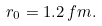<formula> <loc_0><loc_0><loc_500><loc_500>r _ { 0 } = 1 . 2 \, f m .</formula> 